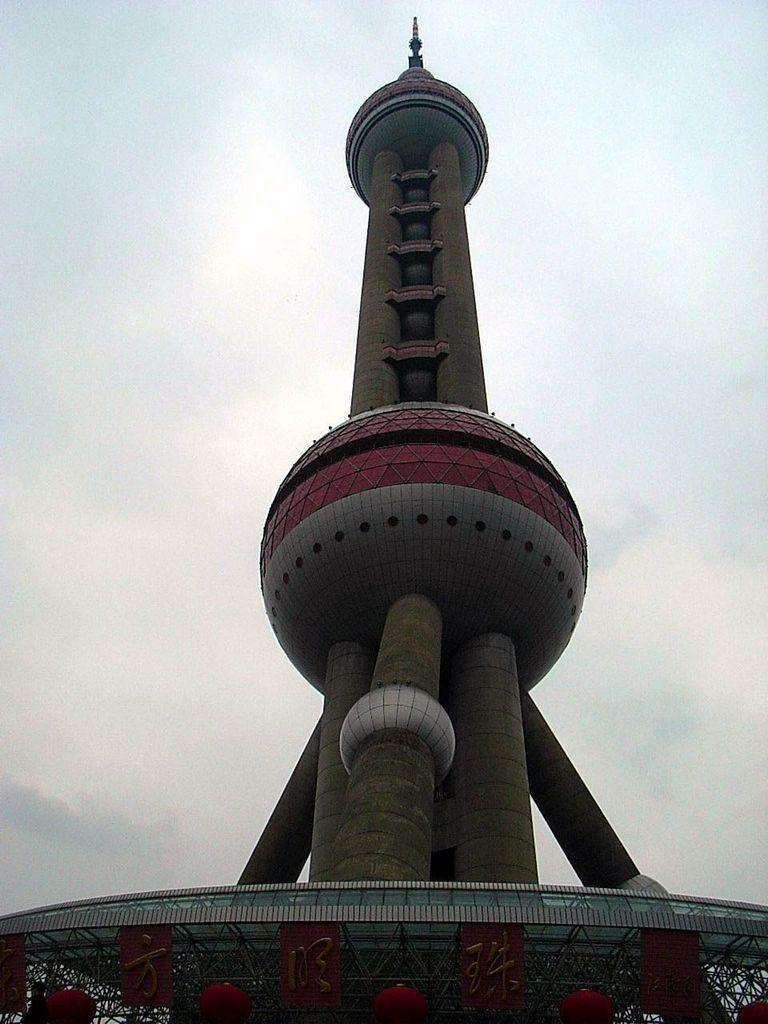What can be seen in the background of the image? The sky is visible in the background of the image. What type of structure is present in the image? There is an architectural structure in the image. What materials are present at the bottom portion of the image? Beams and boards are present at the bottom portion of the image. What other objects can be seen at the bottom portion of the image? There are other objects at the bottom portion of the image. Can you read the letter that is being delivered in the image? There is no letter or delivery depicted in the image. What type of hearing aid is visible on the architectural structure in the image? There is no hearing aid present in the image. 